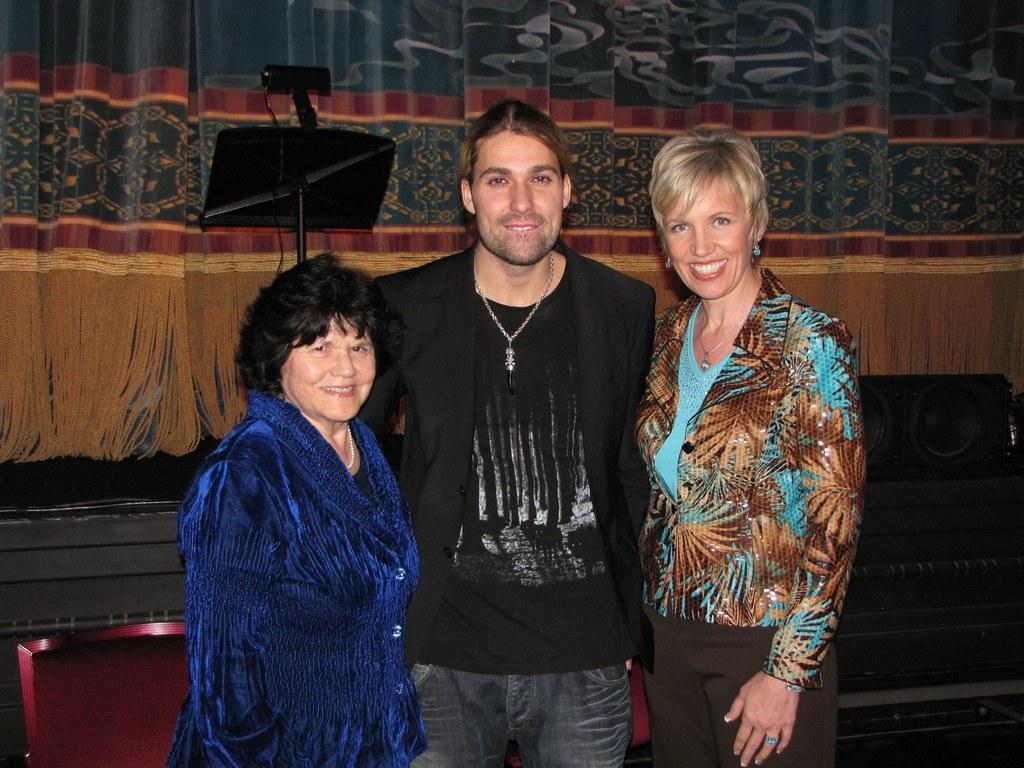How would you summarize this image in a sentence or two? In this picture we can see a man and two women standing and smiling and in the background we can see a speaker, stand, curtains. 